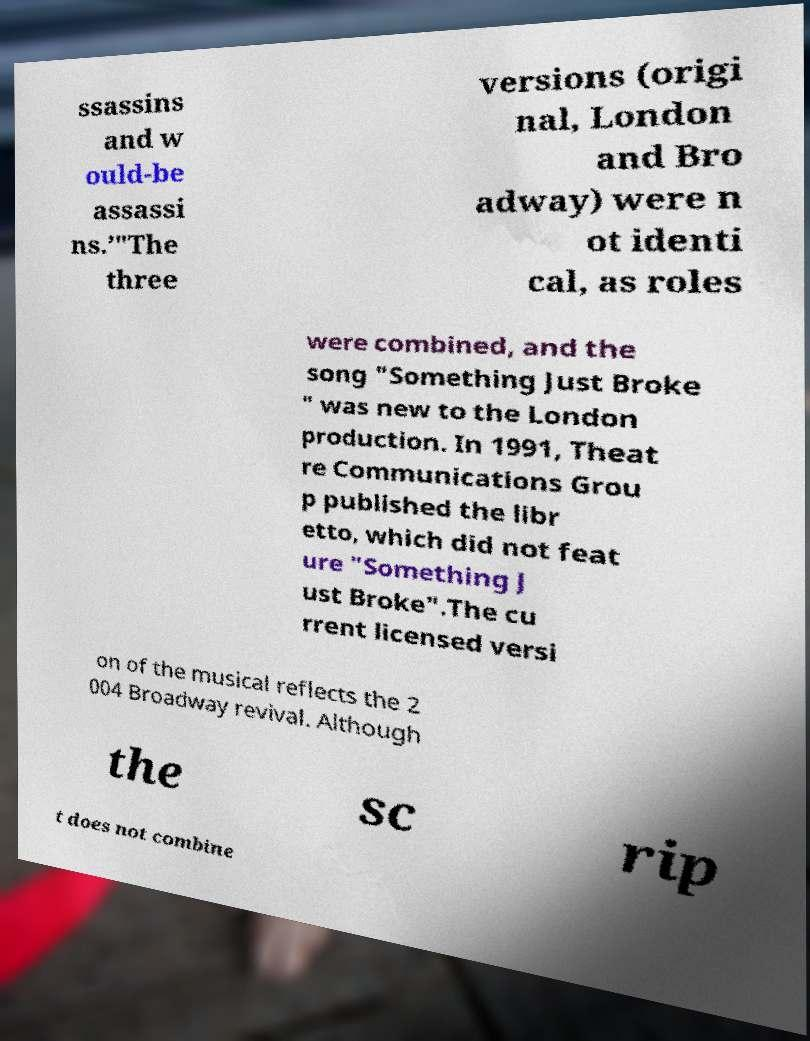I need the written content from this picture converted into text. Can you do that? ssassins and w ould-be assassi ns.’"The three versions (origi nal, London and Bro adway) were n ot identi cal, as roles were combined, and the song "Something Just Broke " was new to the London production. In 1991, Theat re Communications Grou p published the libr etto, which did not feat ure "Something J ust Broke".The cu rrent licensed versi on of the musical reflects the 2 004 Broadway revival. Although the sc rip t does not combine 